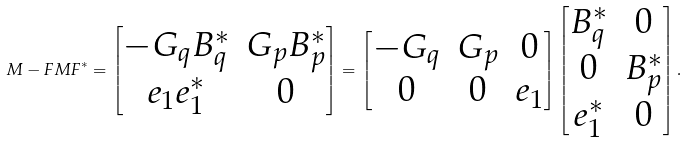<formula> <loc_0><loc_0><loc_500><loc_500>M - F M F ^ { * } = \begin{bmatrix} - G _ { q } B _ { q } ^ { * } & G _ { p } B _ { p } ^ { * } \\ e _ { 1 } e _ { 1 } ^ { * } & 0 \end{bmatrix} = \begin{bmatrix} - G _ { q } & G _ { p } & 0 \\ 0 & 0 & e _ { 1 } \end{bmatrix} \begin{bmatrix} B _ { q } ^ { * } & 0 \\ 0 & B _ { p } ^ { * } \\ e _ { 1 } ^ { * } & 0 \end{bmatrix} .</formula> 